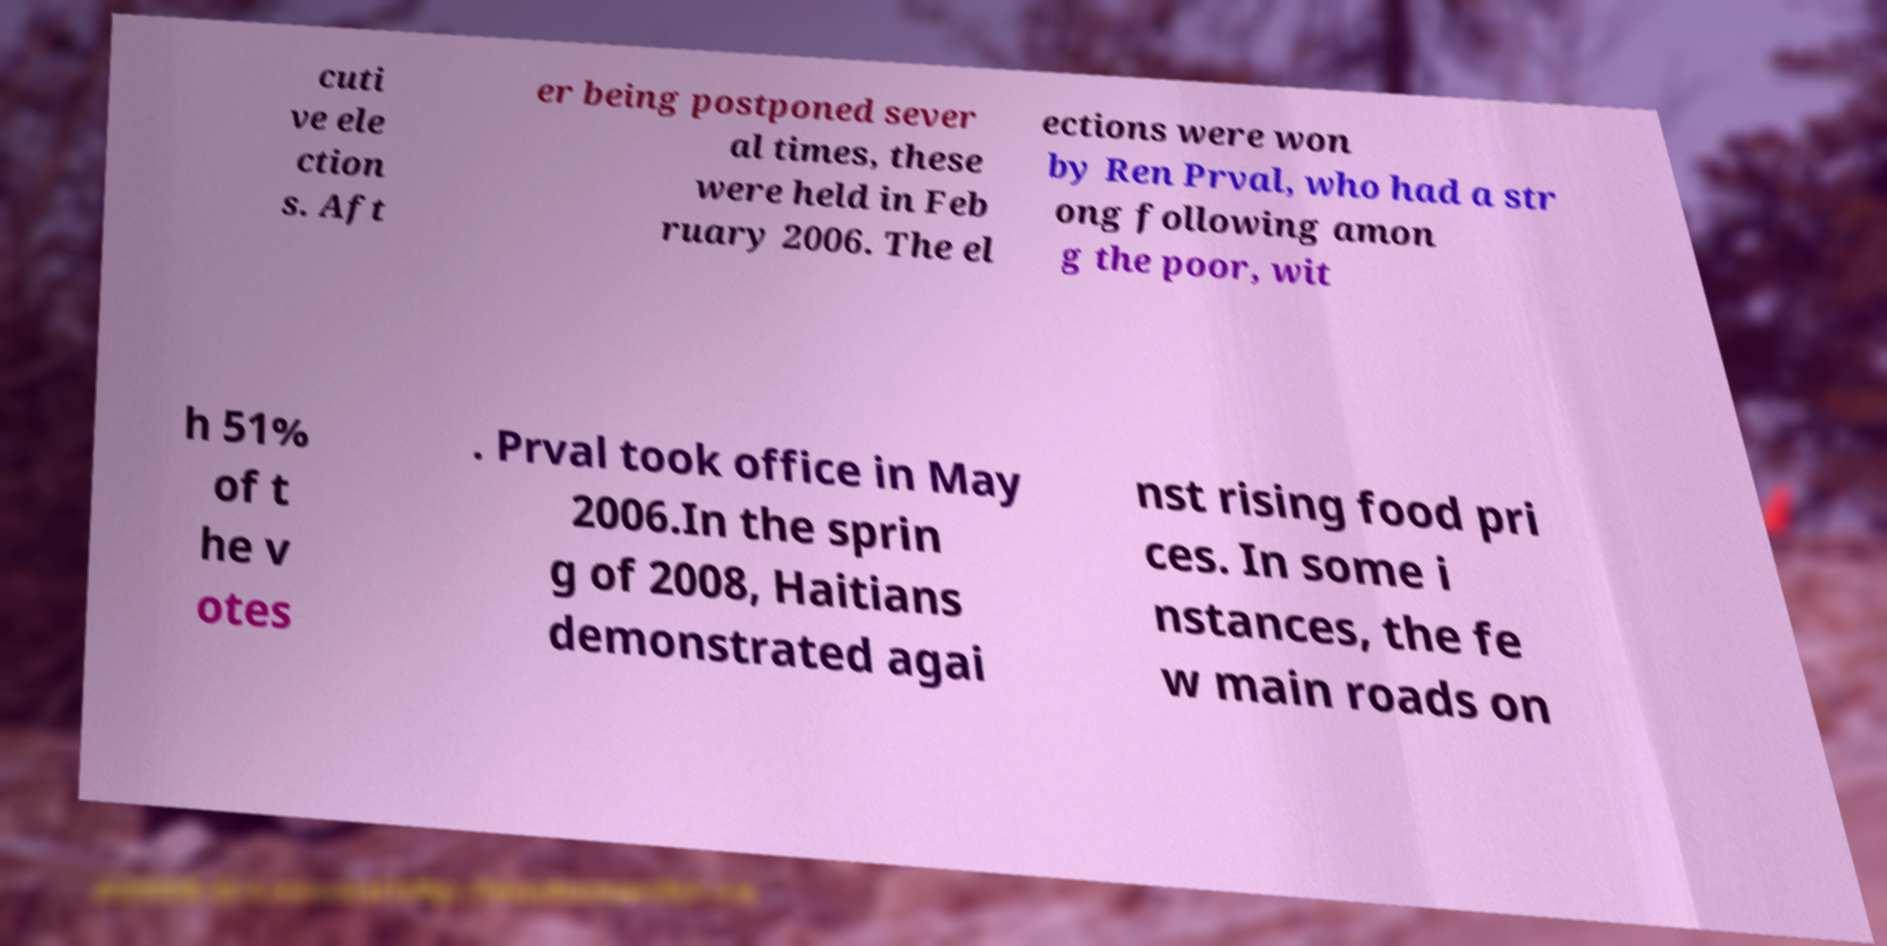What messages or text are displayed in this image? I need them in a readable, typed format. cuti ve ele ction s. Aft er being postponed sever al times, these were held in Feb ruary 2006. The el ections were won by Ren Prval, who had a str ong following amon g the poor, wit h 51% of t he v otes . Prval took office in May 2006.In the sprin g of 2008, Haitians demonstrated agai nst rising food pri ces. In some i nstances, the fe w main roads on 